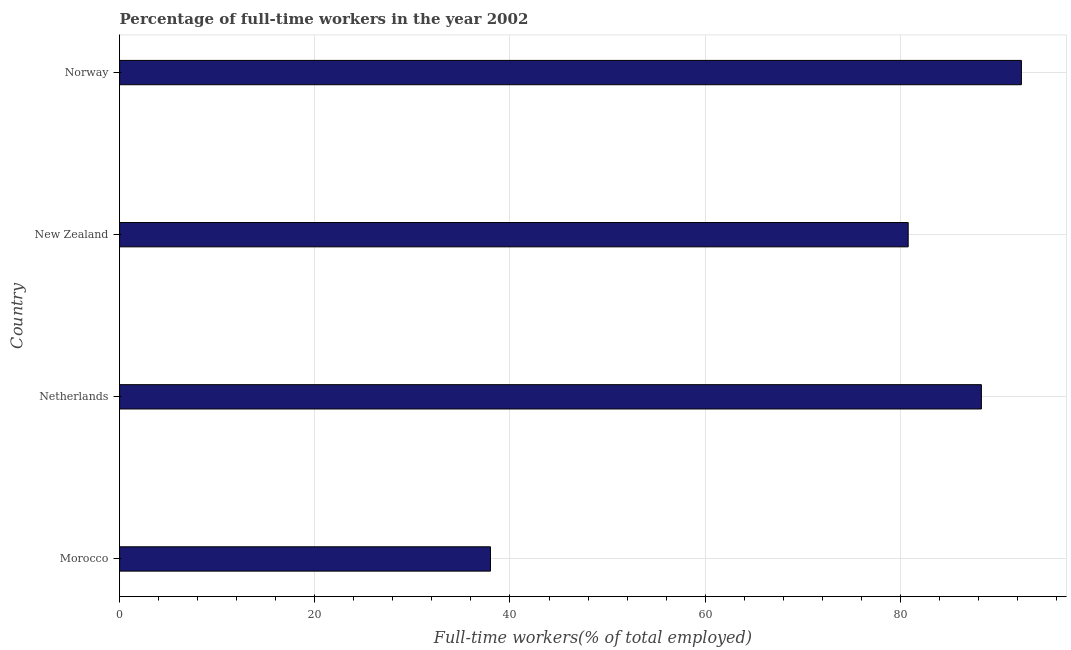Does the graph contain grids?
Make the answer very short. Yes. What is the title of the graph?
Ensure brevity in your answer.  Percentage of full-time workers in the year 2002. What is the label or title of the X-axis?
Ensure brevity in your answer.  Full-time workers(% of total employed). What is the label or title of the Y-axis?
Ensure brevity in your answer.  Country. What is the percentage of full-time workers in New Zealand?
Your response must be concise. 80.8. Across all countries, what is the maximum percentage of full-time workers?
Your answer should be compact. 92.4. In which country was the percentage of full-time workers maximum?
Make the answer very short. Norway. In which country was the percentage of full-time workers minimum?
Provide a short and direct response. Morocco. What is the sum of the percentage of full-time workers?
Give a very brief answer. 299.5. What is the difference between the percentage of full-time workers in Morocco and Norway?
Provide a succinct answer. -54.4. What is the average percentage of full-time workers per country?
Ensure brevity in your answer.  74.88. What is the median percentage of full-time workers?
Provide a short and direct response. 84.55. What is the ratio of the percentage of full-time workers in Netherlands to that in New Zealand?
Offer a terse response. 1.09. Is the difference between the percentage of full-time workers in Morocco and Netherlands greater than the difference between any two countries?
Make the answer very short. No. What is the difference between the highest and the second highest percentage of full-time workers?
Offer a very short reply. 4.1. Is the sum of the percentage of full-time workers in Morocco and Netherlands greater than the maximum percentage of full-time workers across all countries?
Your response must be concise. Yes. What is the difference between the highest and the lowest percentage of full-time workers?
Give a very brief answer. 54.4. What is the Full-time workers(% of total employed) of Morocco?
Ensure brevity in your answer.  38. What is the Full-time workers(% of total employed) in Netherlands?
Offer a very short reply. 88.3. What is the Full-time workers(% of total employed) in New Zealand?
Offer a terse response. 80.8. What is the Full-time workers(% of total employed) of Norway?
Provide a short and direct response. 92.4. What is the difference between the Full-time workers(% of total employed) in Morocco and Netherlands?
Keep it short and to the point. -50.3. What is the difference between the Full-time workers(% of total employed) in Morocco and New Zealand?
Give a very brief answer. -42.8. What is the difference between the Full-time workers(% of total employed) in Morocco and Norway?
Keep it short and to the point. -54.4. What is the difference between the Full-time workers(% of total employed) in Netherlands and New Zealand?
Your answer should be compact. 7.5. What is the ratio of the Full-time workers(% of total employed) in Morocco to that in Netherlands?
Your answer should be compact. 0.43. What is the ratio of the Full-time workers(% of total employed) in Morocco to that in New Zealand?
Ensure brevity in your answer.  0.47. What is the ratio of the Full-time workers(% of total employed) in Morocco to that in Norway?
Your answer should be compact. 0.41. What is the ratio of the Full-time workers(% of total employed) in Netherlands to that in New Zealand?
Offer a terse response. 1.09. What is the ratio of the Full-time workers(% of total employed) in Netherlands to that in Norway?
Your response must be concise. 0.96. What is the ratio of the Full-time workers(% of total employed) in New Zealand to that in Norway?
Ensure brevity in your answer.  0.87. 